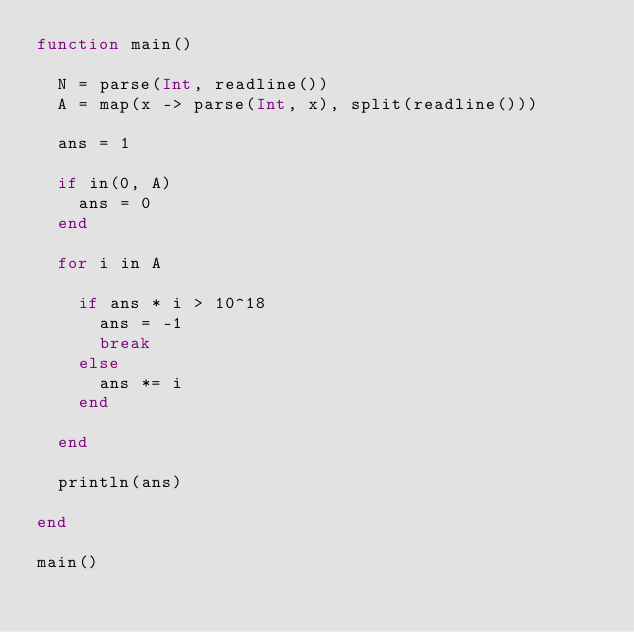<code> <loc_0><loc_0><loc_500><loc_500><_Julia_>function main()
  
  N = parse(Int, readline())
  A = map(x -> parse(Int, x), split(readline()))
  
  ans = 1
  
  if in(0, A)
    ans = 0
  end
  
  for i in A
    
    if ans * i > 10^18
      ans = -1
      break
    else
      ans *= i
    end
    
  end
  
  println(ans)
  
end

main()</code> 